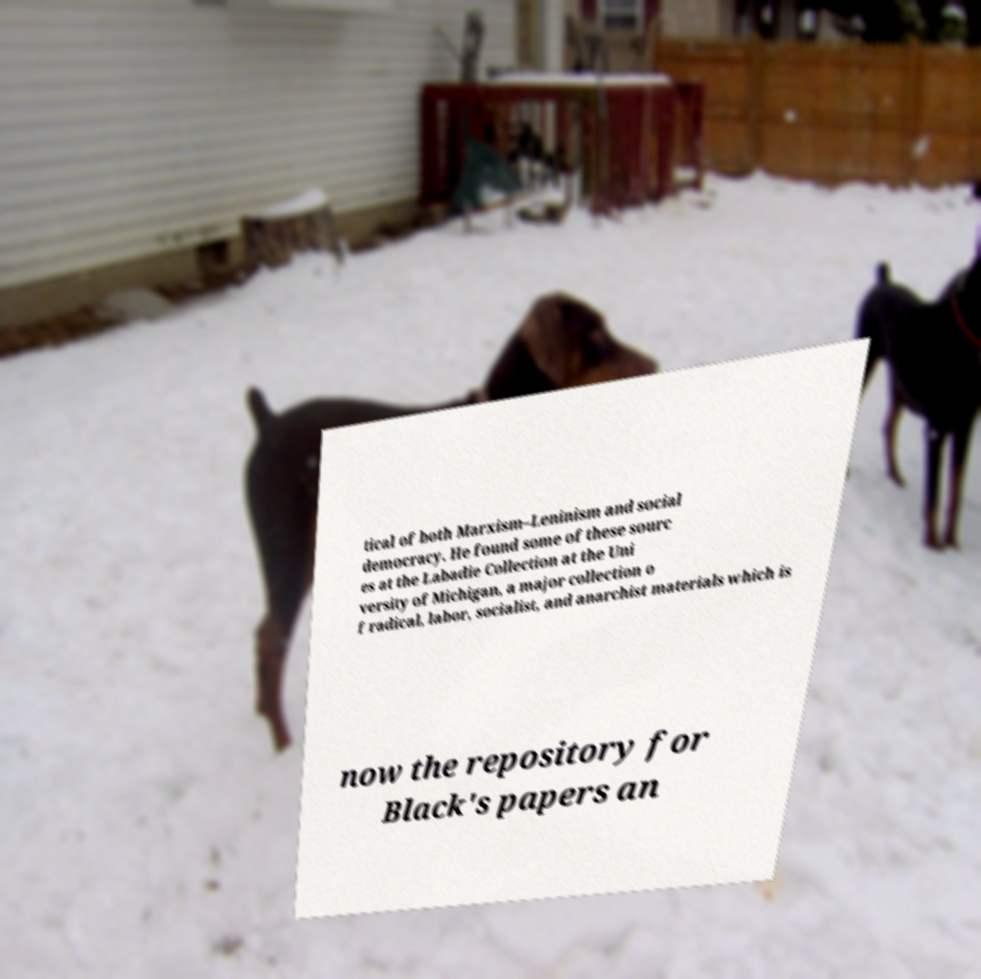Can you read and provide the text displayed in the image?This photo seems to have some interesting text. Can you extract and type it out for me? tical of both Marxism–Leninism and social democracy. He found some of these sourc es at the Labadie Collection at the Uni versity of Michigan, a major collection o f radical, labor, socialist, and anarchist materials which is now the repository for Black's papers an 